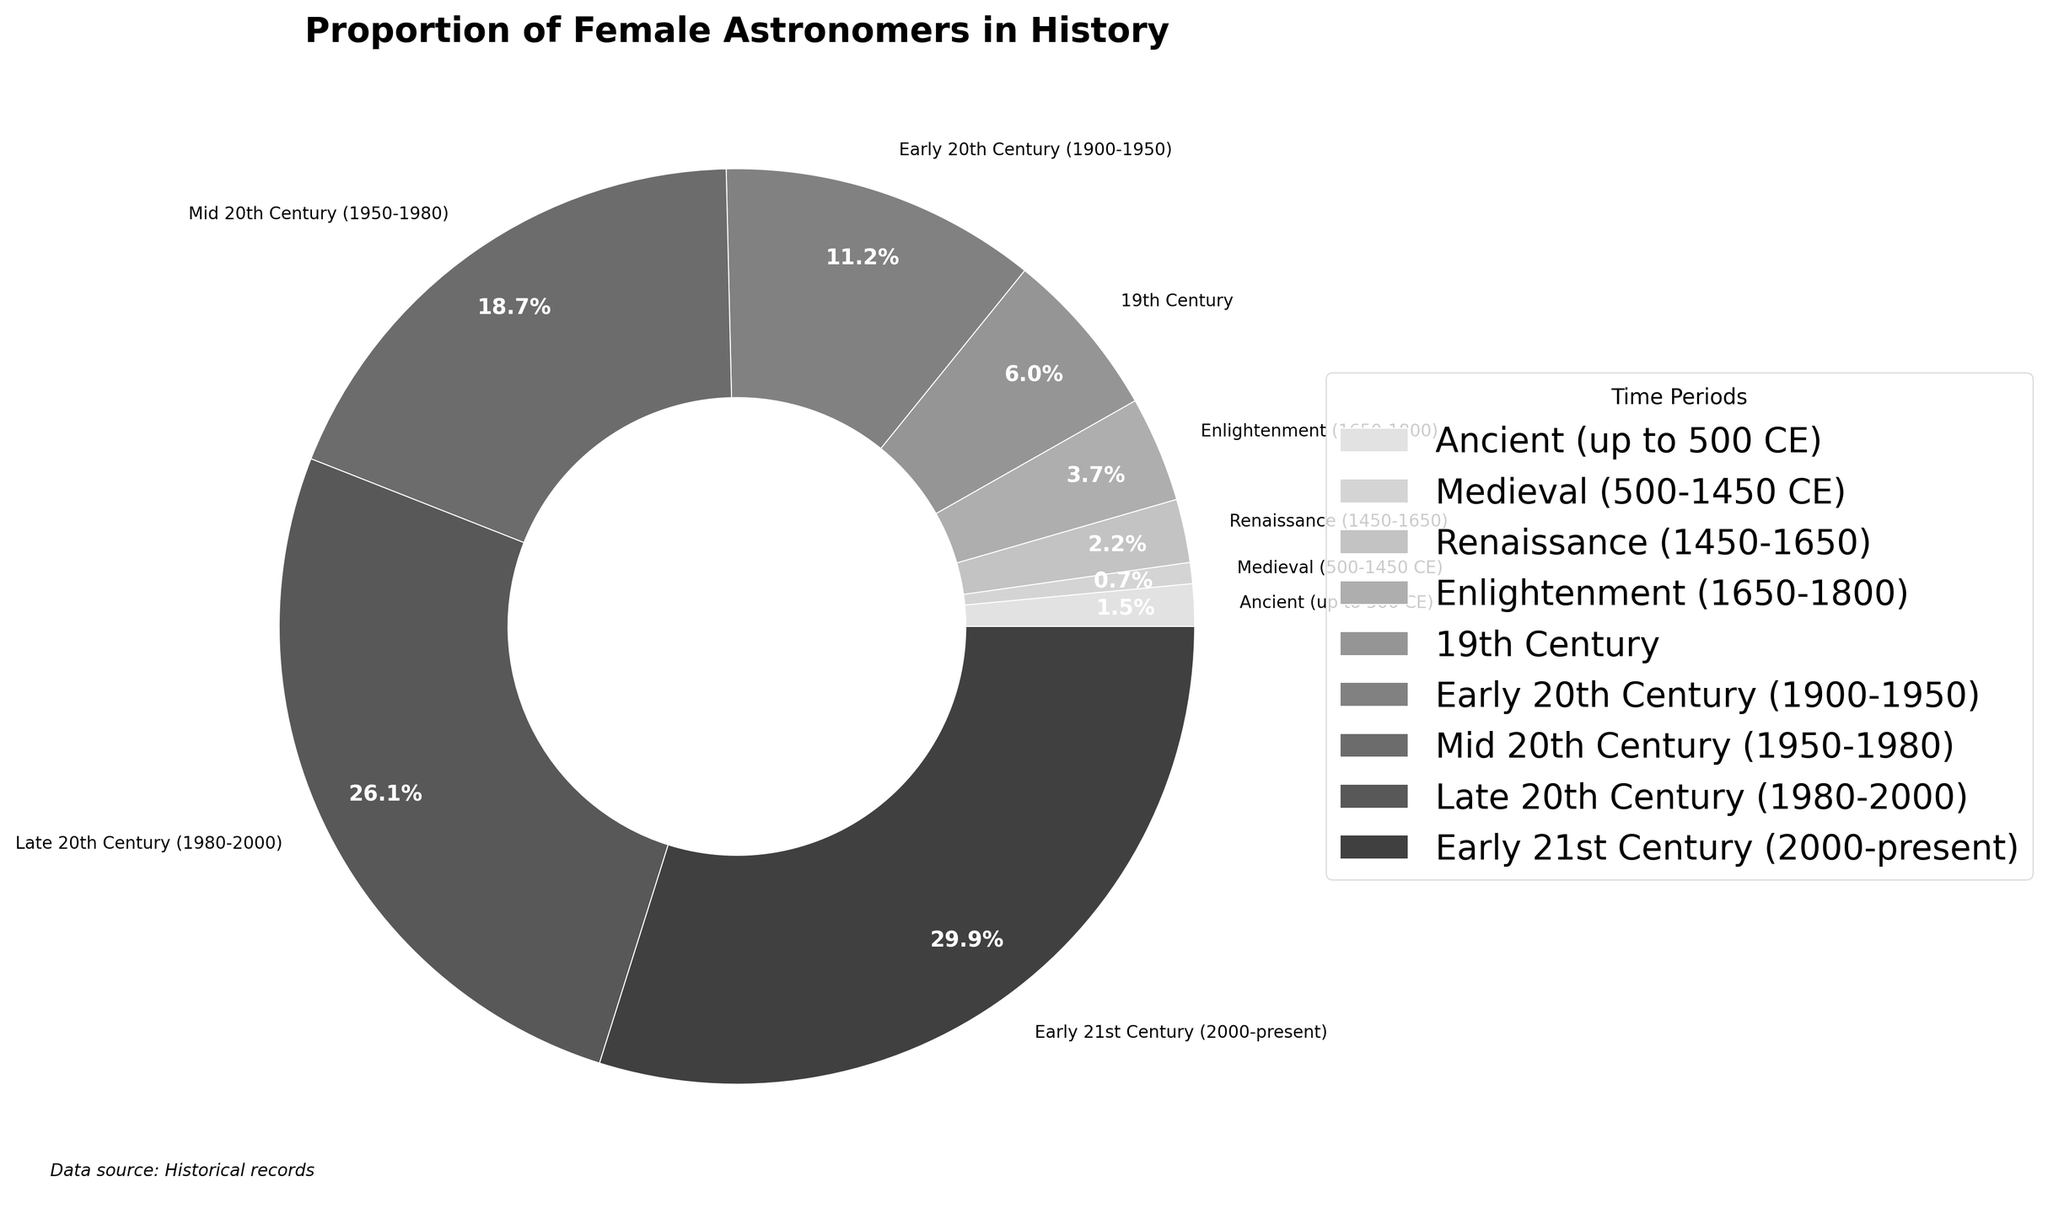What time period had the highest percentage of female astronomers? The time period with the highest percentage of female astronomers can be identified by looking at the slice of the pie chart that has the largest size. According to the chart, the Early 21st Century (2000-present) has a 40% representation of female astronomers.
Answer: Early 21st Century (2000-present) How many time periods have a lower proportion of female astronomers compared to the Renaissance? The pie chart shows the percentage of female astronomers for each time period. The Renaissance has a 3% representation. Time periods with a lower percentage are Ancient (2%) and Medieval (1%). Therefore, 2 time periods have a lower proportion of female astronomers.
Answer: 2 What is the difference in the percentage of female astronomers between the Mid 20th Century and the Enlightenment? To find the difference, subtract the percentage of female astronomers during the Enlightenment (5%) from the percentage during the Mid 20th Century (25%). The difference is 25% - 5% = 20%.
Answer: 20% Between which two consecutive time periods did the proportion of female astronomers increase the most? To determine this, calculate the differences between consecutive time periods. The largest increase is between the Mid 20th Century (25%) and Late 20th Century (35%), which is a 10% increase.
Answer: Mid 20th Century and Late 20th Century What percentage of female astronomers existed during the 19th Century? The 19th Century slice on the pie chart shows the data directly. Referring to the chart, the percentage of female astronomers in the 19th Century is 8%.
Answer: 8% Which century had a more significant proportion of female astronomers, the 19th or the Early 20th? By comparing the sizes of the slices for each century, we find that the 19th Century has 8% and the Early 20th Century (1900-1950) has 15%. Hence, the Early 20th Century had a more significant proportion.
Answer: Early 20th Century What is the combined percentage of female astronomers from the Medieval and Enlightenment periods? The combined percentage is determined by adding the two percentages together. For the Medieval period (1%) and Enlightenment (5%), the total is 1% + 5% = 6%.
Answer: 6% How much did the proportion of female astronomers increase from Ancient times to the Early 21st Century? The percentage in Ancient times was 2%, and in the Early 21st Century, it is 40%. The increase is 40% - 2% = 38%.
Answer: 38% What color represents the Late 20th Century in the chart? Referring to the grayscale colors used in the chart, the segment representing the Late 20th Century is visually indicated as being in a lighter grey shade among the darker slices. Check the legend if detailed differentiation is needed.
Answer: Lighter grey 